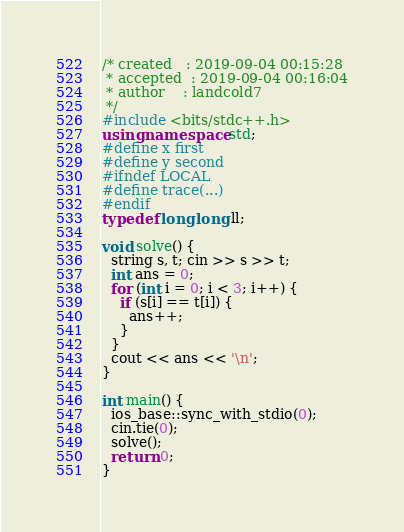Convert code to text. <code><loc_0><loc_0><loc_500><loc_500><_C++_>/* created   : 2019-09-04 00:15:28
 * accepted  : 2019-09-04 00:16:04
 * author    : landcold7
 */
#include <bits/stdc++.h>
using namespace std;
#define x first
#define y second
#ifndef LOCAL
#define trace(...)
#endif
typedef long long ll;

void solve() {
  string s, t; cin >> s >> t;
  int ans = 0;
  for (int i = 0; i < 3; i++) {
    if (s[i] == t[i]) {
      ans++;
    }
  }
  cout << ans << '\n';
}

int main() {
  ios_base::sync_with_stdio(0);
  cin.tie(0);
  solve();
  return 0;
}
</code> 